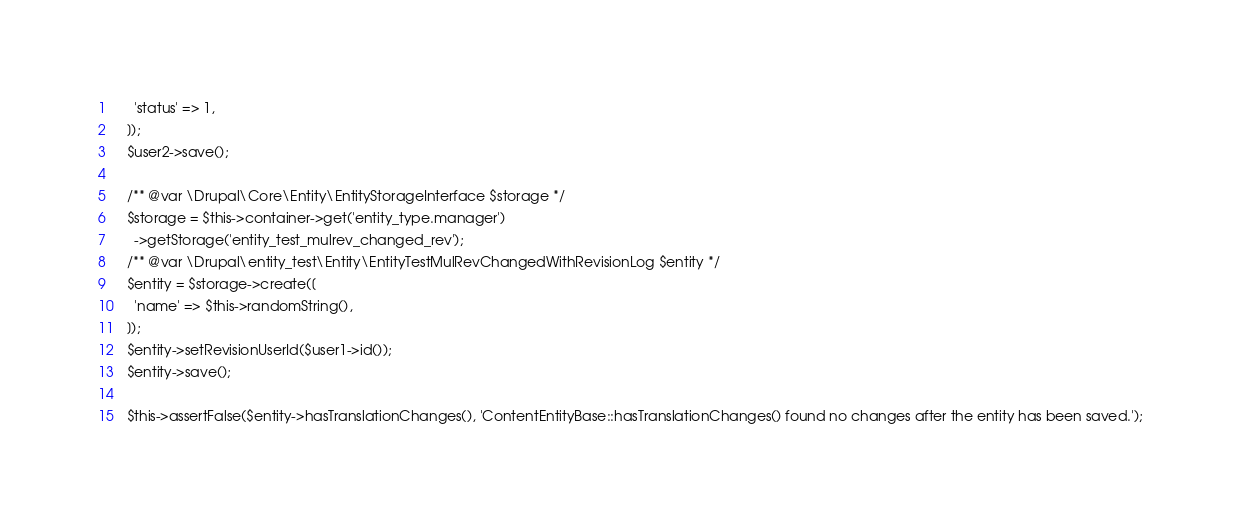Convert code to text. <code><loc_0><loc_0><loc_500><loc_500><_PHP_>      'status' => 1,
    ]);
    $user2->save();

    /** @var \Drupal\Core\Entity\EntityStorageInterface $storage */
    $storage = $this->container->get('entity_type.manager')
      ->getStorage('entity_test_mulrev_changed_rev');
    /** @var \Drupal\entity_test\Entity\EntityTestMulRevChangedWithRevisionLog $entity */
    $entity = $storage->create([
      'name' => $this->randomString(),
    ]);
    $entity->setRevisionUserId($user1->id());
    $entity->save();

    $this->assertFalse($entity->hasTranslationChanges(), 'ContentEntityBase::hasTranslationChanges() found no changes after the entity has been saved.');
</code> 